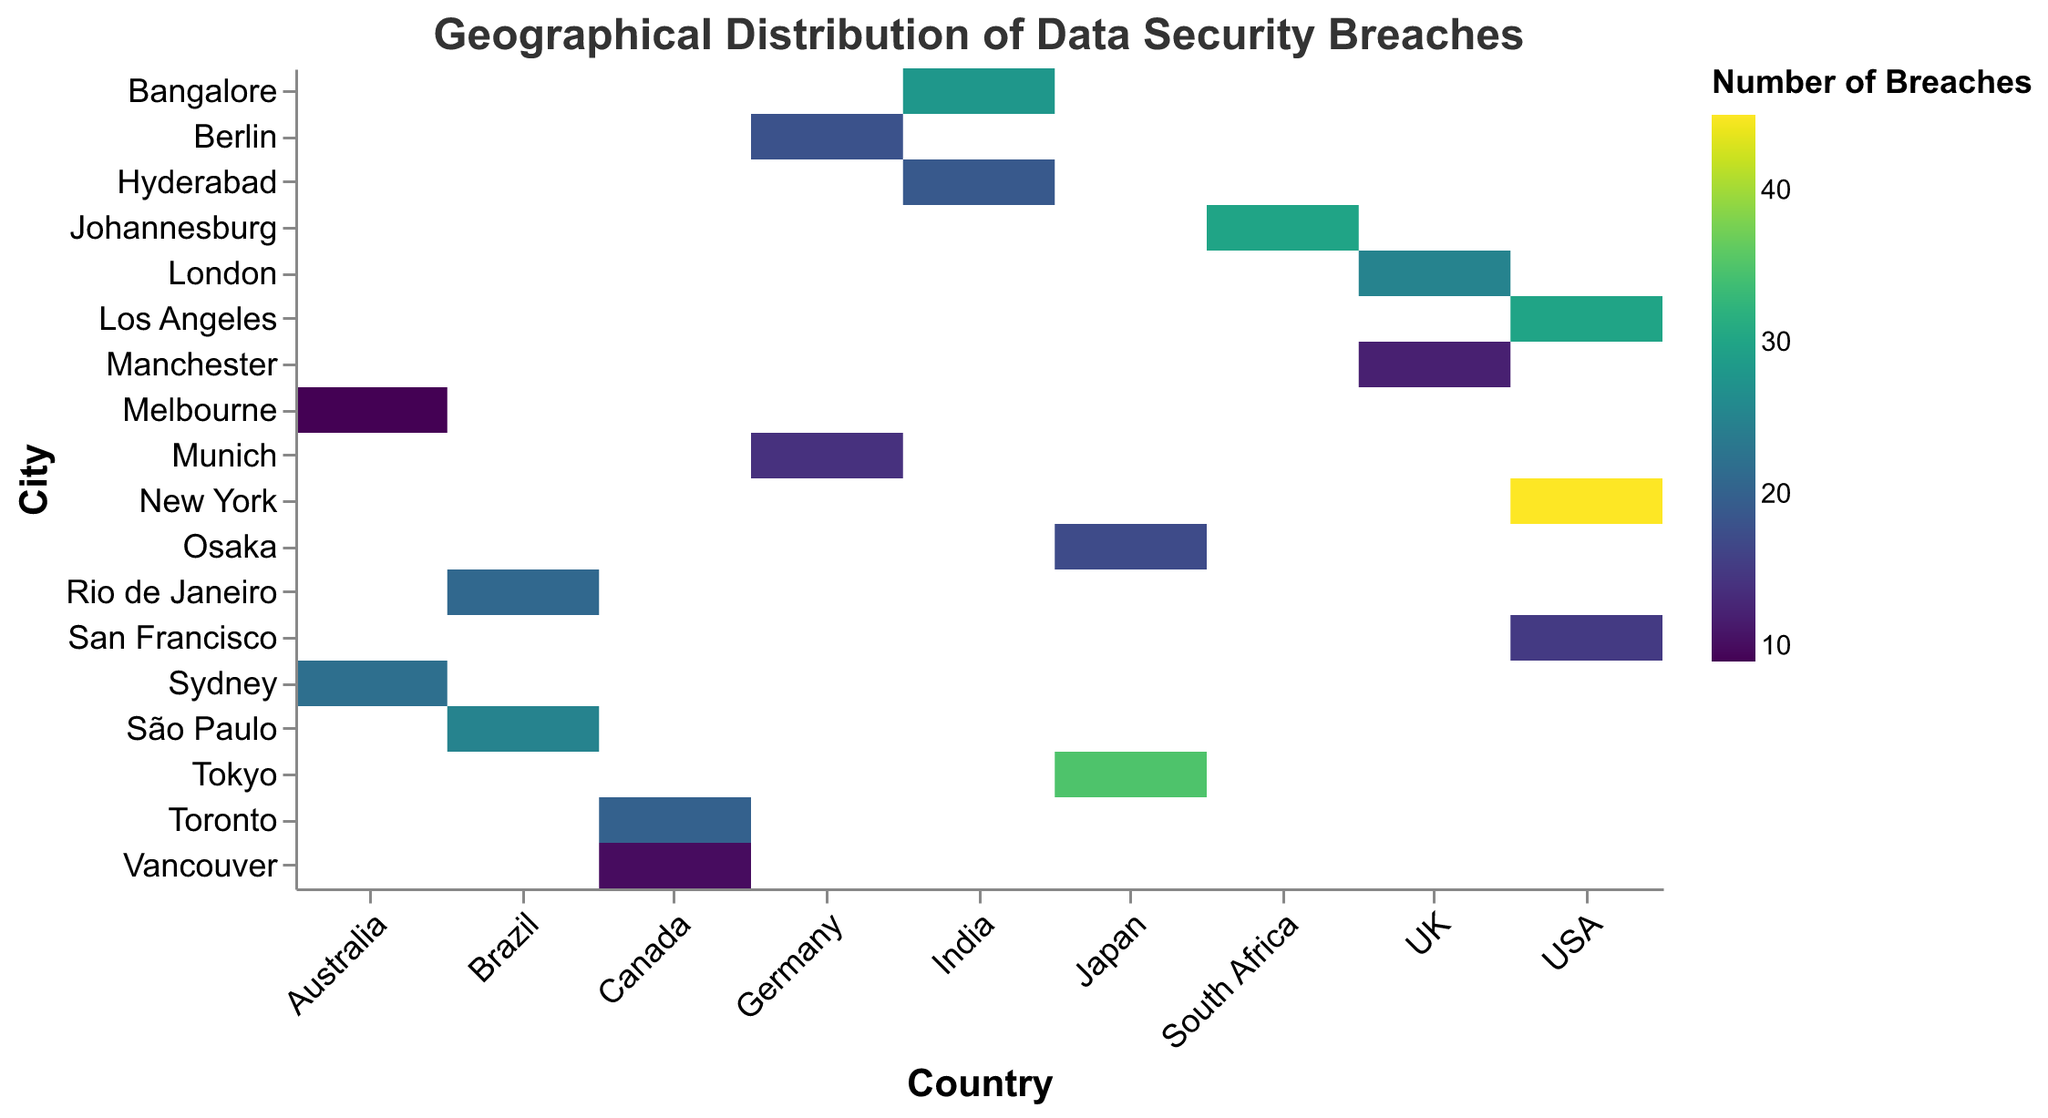What city in the USA has the highest number of data security breaches? Look for the cities listed under the "Country" column with "USA" as the country. Compare the values in the "Number_of_Breaches" column. New York has 45 breaches, which is the highest.
Answer: New York Which country has the city with the lowest number of data security breaches? Identify the cities with the lowest breach numbers in the "Number_of_Breaches" column. Vancouver in Canada and Melbourne in Australia both have 9 breaches each. Selecting either country is correct.
Answer: Canada or Australia What's the total number of data security breaches in Brazil? Locate the entries for Brazil, then sum the values in the "Number_of_Breaches" column. São Paulo has 25 breaches and Rio de Janeiro has 21 breaches, totaling 46.
Answer: 46 Which country has the highest number of high-severity data security breaches? Filter by "Severity_Level" as "High" and then compare the total breaches for each country. USA has New York with 45 breaches, the highest of all.
Answer: USA What is the difference in the number of data security breaches between Tokyo and Osaka? Locate the entries for Tokyo and Osaka, and note their breach numbers, 35 and 17 respectively. Subtract 17 from 35 to get 18.
Answer: 18 In which city of India do moderate-severity data security breaches occur? Look for the entries with "Country" as India and "Severity_Level" as "Moderate". Hyderabad reports moderate-severity breaches.
Answer: Hyderabad Which city has the highest number of low-severity data security breaches? Locate the entries with "Severity_Level" set to "Low" and identify the highest number of breaches. San Francisco has the highest breach count of 15.
Answer: San Francisco What is the total number of data security breaches in cities with high severity in Asia? Identify Asian cities with a high severity level: Tokyo (35), Bangalore (28), and Bangalore (30). Summing these up gives 93 (35+28+30).
Answer: 93 Compare the number of moderate-severity breaches between Los Angeles and Sydney. Which city has more? Locate moderate-severity breaches for Los Angeles (30) and Sydney (22). Los Angeles has more breaches.
Answer: Los Angeles Which city in the UK has fewer data security breaches, London or Manchester? Look at the values for London (25 breaches) and Manchester (12 breaches). Manchester has fewer breaches.
Answer: Manchester 